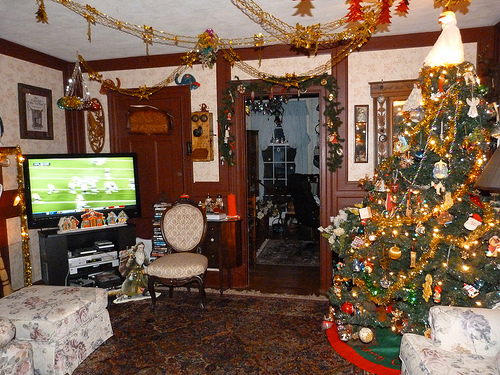<image>
Is there a chair under the window? No. The chair is not positioned under the window. The vertical relationship between these objects is different. Where is the tree skirt in relation to the christmas tree? Is it next to the christmas tree? No. The tree skirt is not positioned next to the christmas tree. They are located in different areas of the scene. 